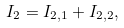Convert formula to latex. <formula><loc_0><loc_0><loc_500><loc_500>I _ { 2 } = I _ { 2 , 1 } + I _ { 2 , 2 } ,</formula> 